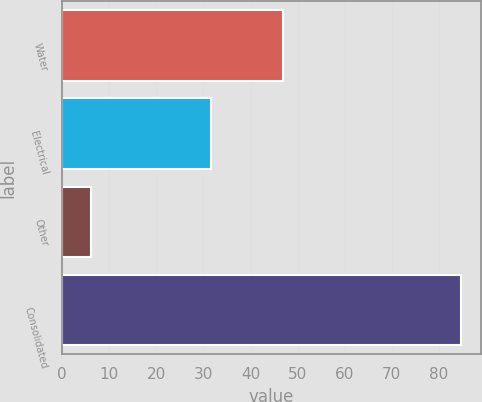<chart> <loc_0><loc_0><loc_500><loc_500><bar_chart><fcel>Water<fcel>Electrical<fcel>Other<fcel>Consolidated<nl><fcel>46.8<fcel>31.6<fcel>6.2<fcel>84.6<nl></chart> 